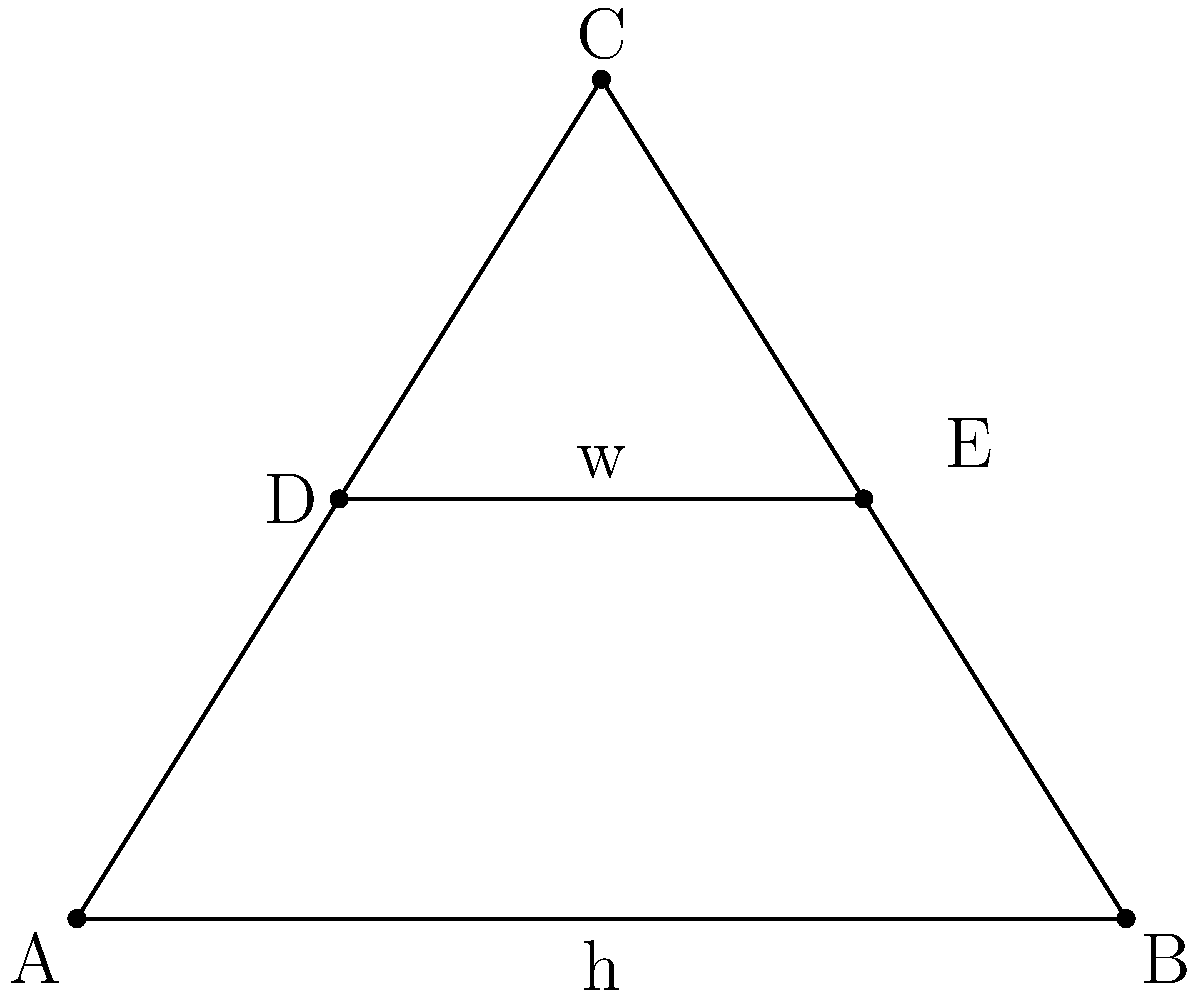In a Gothic arch, the ratio of the width (w) to the height (h) is crucial for structural stability. Consider the equilateral triangle ABC representing a Gothic arch, where AB is the base and C is the apex. If DE is a horizontal line segment connecting the midpoints of AC and BC, and the length of AB is 10 meters, what is the ratio of DE to AB? Let's approach this step-by-step:

1) In an equilateral triangle, the height (h) can be calculated using the formula:
   $$h = \frac{\sqrt{3}}{2} * base$$

2) Given that AB = 10 meters, we can calculate the height:
   $$h = \frac{\sqrt{3}}{2} * 10 = 5\sqrt{3}$$ meters

3) DE is a line segment connecting the midpoints of the sides of the triangle. In any triangle, such a line segment is parallel to the base and half the length of the base.

4) Therefore, the length of DE is:
   $$DE = \frac{1}{2} * AB = \frac{1}{2} * 10 = 5$$ meters

5) The ratio of DE to AB is:
   $$\frac{DE}{AB} = \frac{5}{10} = \frac{1}{2}$$

This ratio of 1:2 between the width at the midpoint and the base is a characteristic feature of equilateral triangles and, by extension, of many Gothic arches. It contributes to the structural stability and aesthetic appeal of Gothic architecture.
Answer: 1:2 